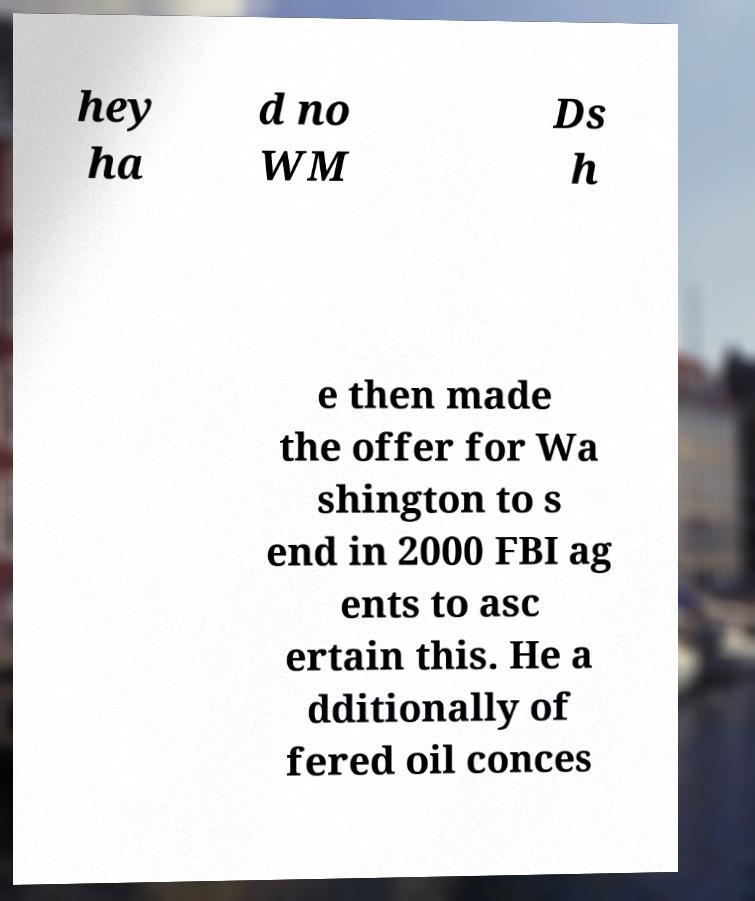Could you assist in decoding the text presented in this image and type it out clearly? hey ha d no WM Ds h e then made the offer for Wa shington to s end in 2000 FBI ag ents to asc ertain this. He a dditionally of fered oil conces 